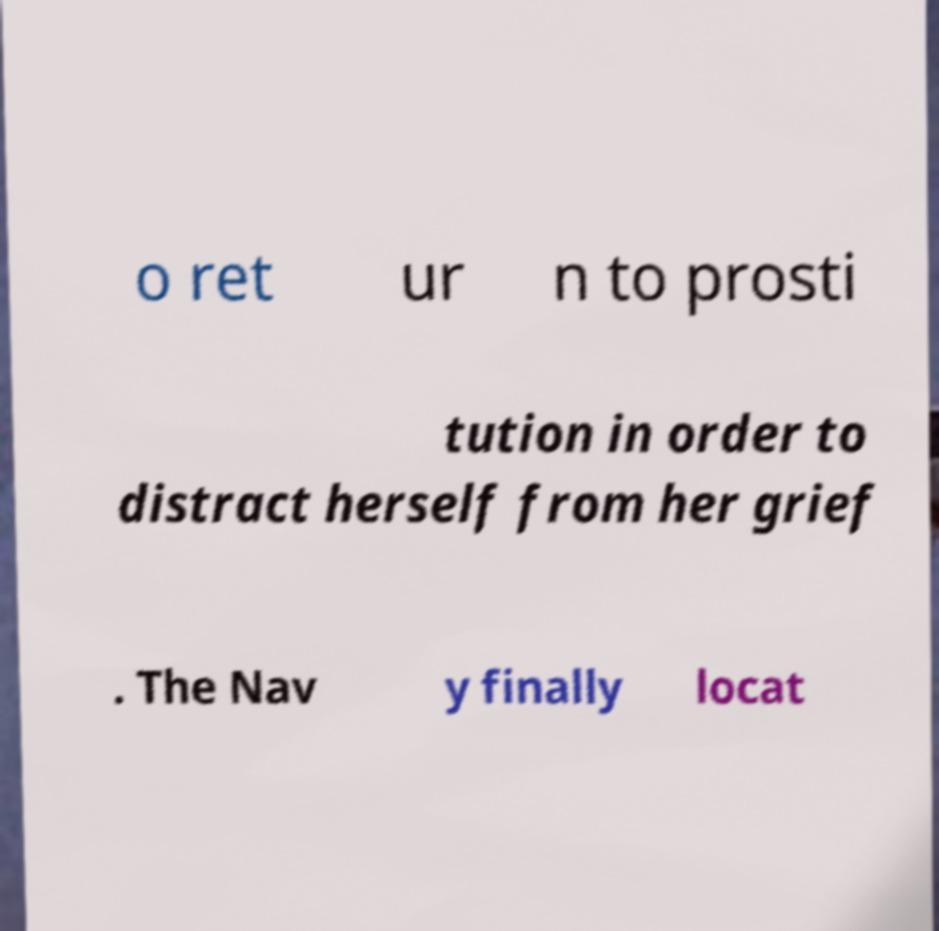For documentation purposes, I need the text within this image transcribed. Could you provide that? o ret ur n to prosti tution in order to distract herself from her grief . The Nav y finally locat 